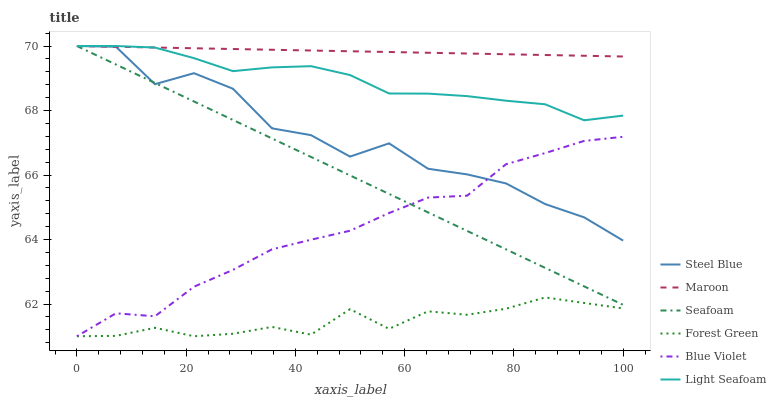Does Forest Green have the minimum area under the curve?
Answer yes or no. Yes. Does Maroon have the maximum area under the curve?
Answer yes or no. Yes. Does Seafoam have the minimum area under the curve?
Answer yes or no. No. Does Seafoam have the maximum area under the curve?
Answer yes or no. No. Is Maroon the smoothest?
Answer yes or no. Yes. Is Steel Blue the roughest?
Answer yes or no. Yes. Is Seafoam the smoothest?
Answer yes or no. No. Is Seafoam the roughest?
Answer yes or no. No. Does Forest Green have the lowest value?
Answer yes or no. Yes. Does Seafoam have the lowest value?
Answer yes or no. No. Does Light Seafoam have the highest value?
Answer yes or no. Yes. Does Forest Green have the highest value?
Answer yes or no. No. Is Forest Green less than Light Seafoam?
Answer yes or no. Yes. Is Seafoam greater than Forest Green?
Answer yes or no. Yes. Does Steel Blue intersect Seafoam?
Answer yes or no. Yes. Is Steel Blue less than Seafoam?
Answer yes or no. No. Is Steel Blue greater than Seafoam?
Answer yes or no. No. Does Forest Green intersect Light Seafoam?
Answer yes or no. No. 